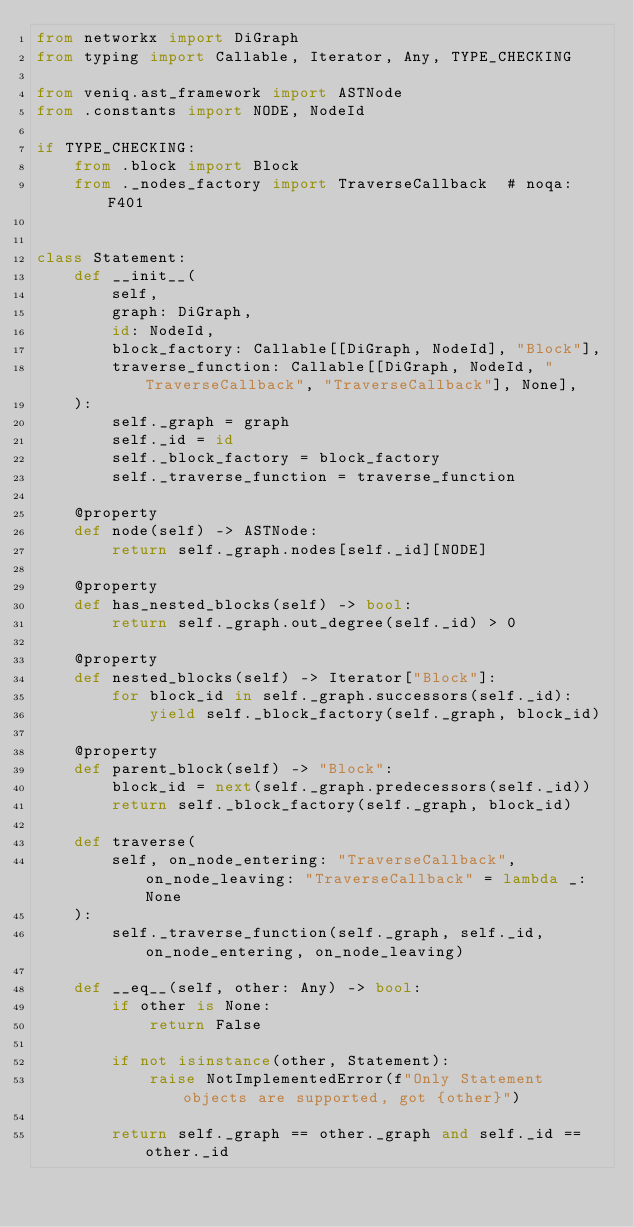<code> <loc_0><loc_0><loc_500><loc_500><_Python_>from networkx import DiGraph
from typing import Callable, Iterator, Any, TYPE_CHECKING

from veniq.ast_framework import ASTNode
from .constants import NODE, NodeId

if TYPE_CHECKING:
    from .block import Block
    from ._nodes_factory import TraverseCallback  # noqa: F401


class Statement:
    def __init__(
        self,
        graph: DiGraph,
        id: NodeId,
        block_factory: Callable[[DiGraph, NodeId], "Block"],
        traverse_function: Callable[[DiGraph, NodeId, "TraverseCallback", "TraverseCallback"], None],
    ):
        self._graph = graph
        self._id = id
        self._block_factory = block_factory
        self._traverse_function = traverse_function

    @property
    def node(self) -> ASTNode:
        return self._graph.nodes[self._id][NODE]

    @property
    def has_nested_blocks(self) -> bool:
        return self._graph.out_degree(self._id) > 0

    @property
    def nested_blocks(self) -> Iterator["Block"]:
        for block_id in self._graph.successors(self._id):
            yield self._block_factory(self._graph, block_id)

    @property
    def parent_block(self) -> "Block":
        block_id = next(self._graph.predecessors(self._id))
        return self._block_factory(self._graph, block_id)

    def traverse(
        self, on_node_entering: "TraverseCallback", on_node_leaving: "TraverseCallback" = lambda _: None
    ):
        self._traverse_function(self._graph, self._id, on_node_entering, on_node_leaving)

    def __eq__(self, other: Any) -> bool:
        if other is None:
            return False

        if not isinstance(other, Statement):
            raise NotImplementedError(f"Only Statement objects are supported, got {other}")

        return self._graph == other._graph and self._id == other._id
</code> 